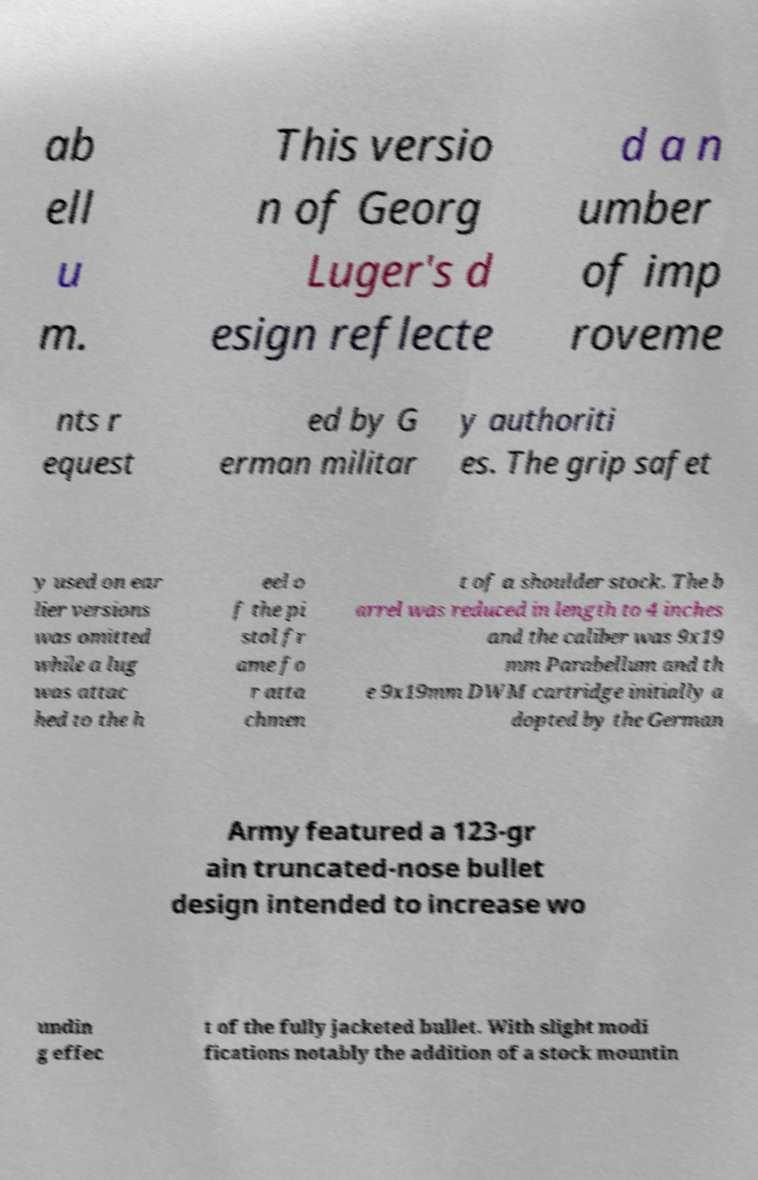I need the written content from this picture converted into text. Can you do that? ab ell u m. This versio n of Georg Luger's d esign reflecte d a n umber of imp roveme nts r equest ed by G erman militar y authoriti es. The grip safet y used on ear lier versions was omitted while a lug was attac hed to the h eel o f the pi stol fr ame fo r atta chmen t of a shoulder stock. The b arrel was reduced in length to 4 inches and the caliber was 9x19 mm Parabellum and th e 9x19mm DWM cartridge initially a dopted by the German Army featured a 123-gr ain truncated-nose bullet design intended to increase wo undin g effec t of the fully jacketed bullet. With slight modi fications notably the addition of a stock mountin 